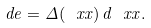Convert formula to latex. <formula><loc_0><loc_0><loc_500><loc_500>d { e } = \Delta ( \ x x ) \, d \ x x .</formula> 